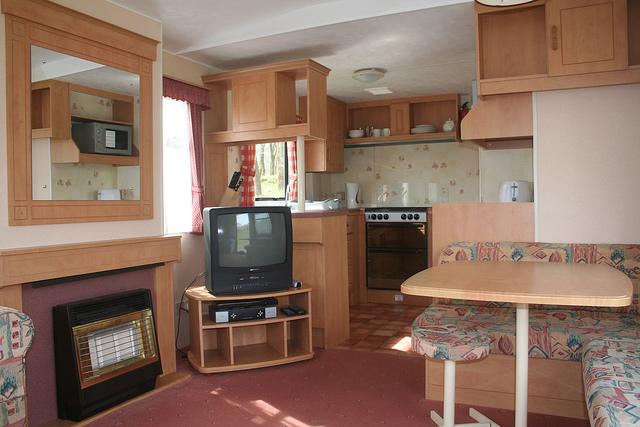How big is the TV screen?
Concise answer only. 27 inches. Would a television like the one in this picture be expensive to buy in a store?
Write a very short answer. No. Is there a stove in the picture?
Write a very short answer. Yes. 